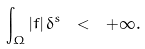<formula> <loc_0><loc_0><loc_500><loc_500>\int _ { \Omega } | f | \, \delta ^ { s } \ < \ + \infty .</formula> 